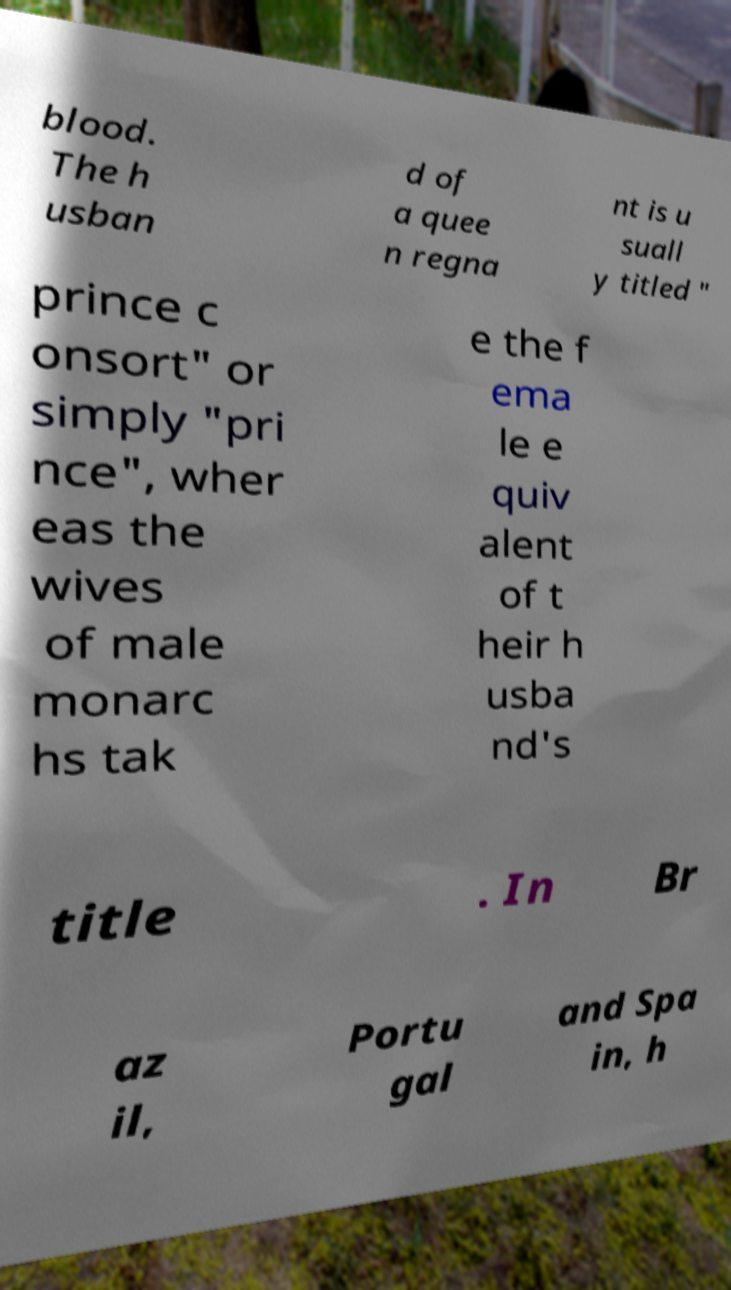Can you accurately transcribe the text from the provided image for me? blood. The h usban d of a quee n regna nt is u suall y titled " prince c onsort" or simply "pri nce", wher eas the wives of male monarc hs tak e the f ema le e quiv alent of t heir h usba nd's title . In Br az il, Portu gal and Spa in, h 